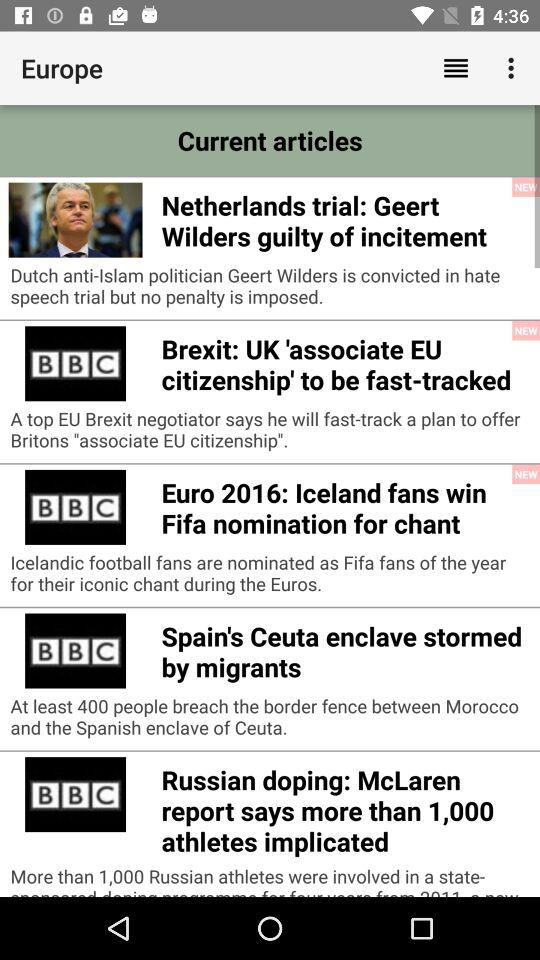Which politician is convicted in a hate speech trial but no penalty is imposed? The politician is Geert Wilders. 